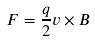<formula> <loc_0><loc_0><loc_500><loc_500>F = \frac { q } { 2 } v \times B</formula> 